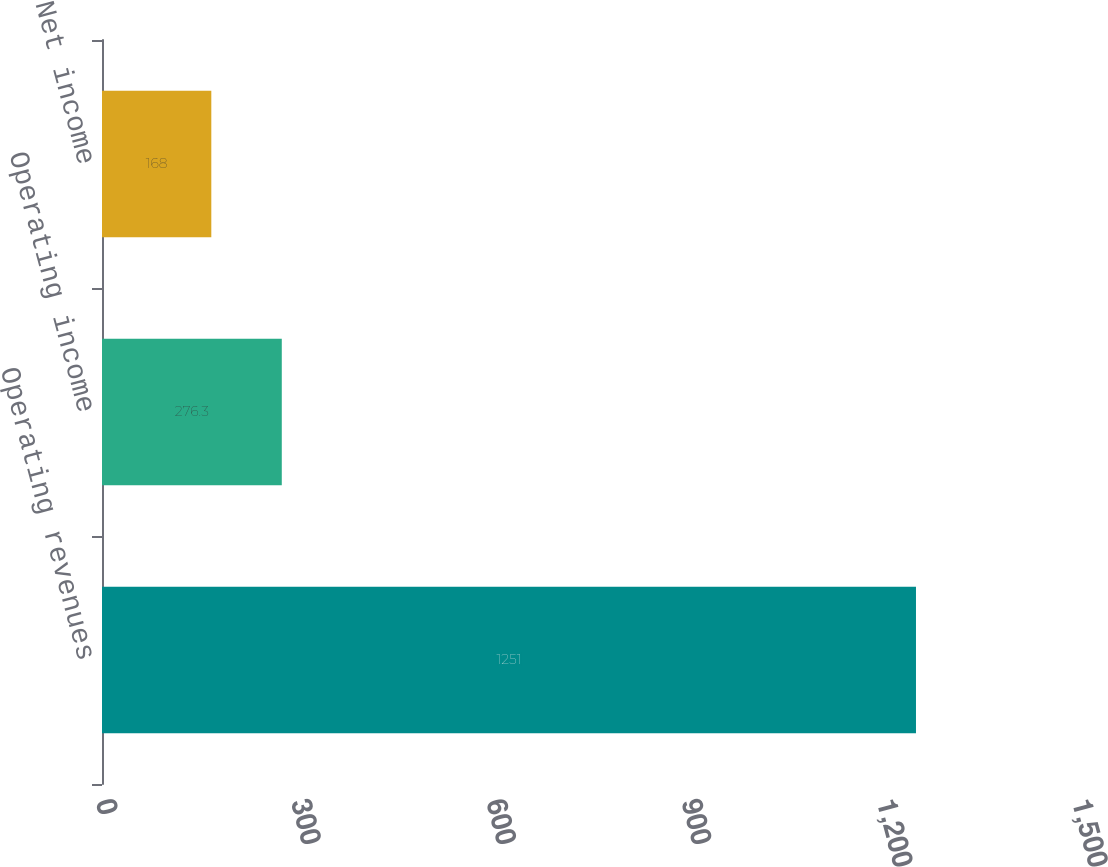Convert chart to OTSL. <chart><loc_0><loc_0><loc_500><loc_500><bar_chart><fcel>Operating revenues<fcel>Operating income<fcel>Net income<nl><fcel>1251<fcel>276.3<fcel>168<nl></chart> 